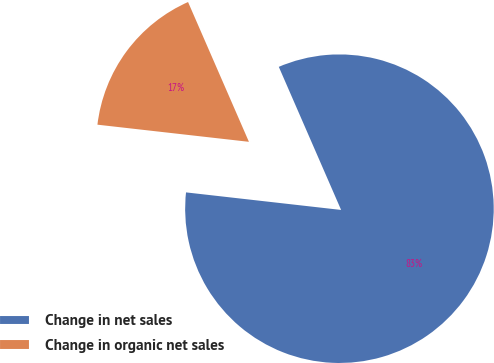Convert chart to OTSL. <chart><loc_0><loc_0><loc_500><loc_500><pie_chart><fcel>Change in net sales<fcel>Change in organic net sales<nl><fcel>83.33%<fcel>16.67%<nl></chart> 